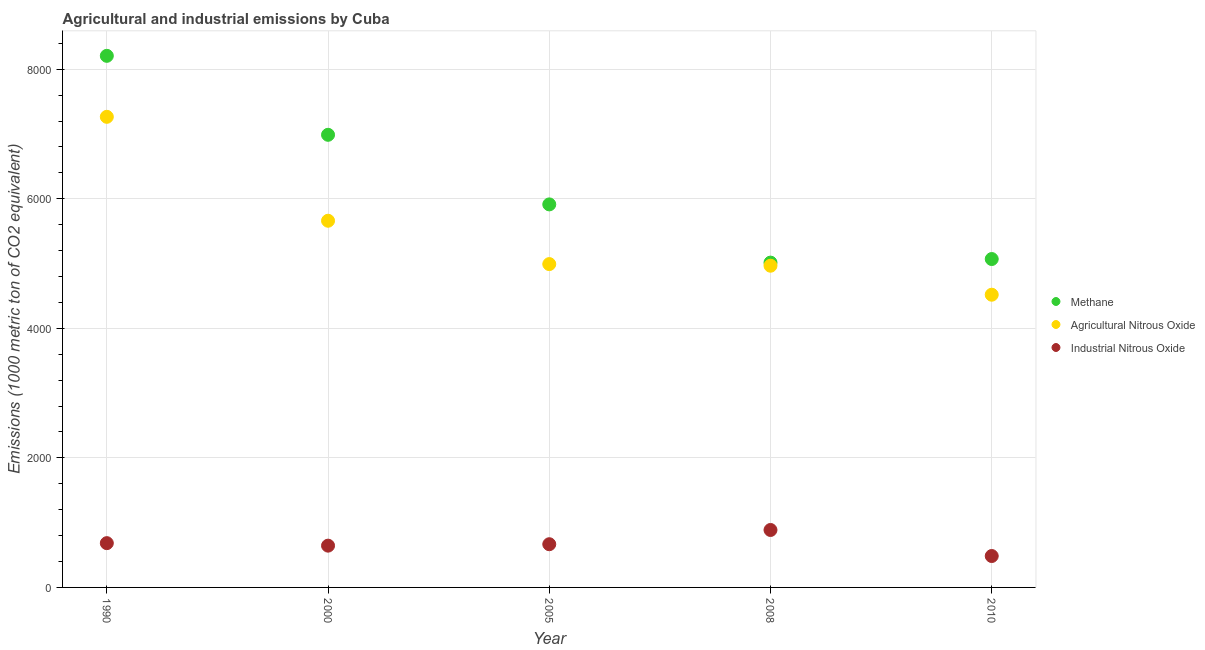Is the number of dotlines equal to the number of legend labels?
Provide a short and direct response. Yes. What is the amount of methane emissions in 1990?
Ensure brevity in your answer.  8207.5. Across all years, what is the maximum amount of methane emissions?
Keep it short and to the point. 8207.5. Across all years, what is the minimum amount of agricultural nitrous oxide emissions?
Provide a succinct answer. 4519.3. In which year was the amount of agricultural nitrous oxide emissions maximum?
Provide a short and direct response. 1990. In which year was the amount of industrial nitrous oxide emissions minimum?
Provide a succinct answer. 2010. What is the total amount of methane emissions in the graph?
Ensure brevity in your answer.  3.12e+04. What is the difference between the amount of agricultural nitrous oxide emissions in 2005 and that in 2008?
Keep it short and to the point. 25.1. What is the difference between the amount of agricultural nitrous oxide emissions in 2010 and the amount of industrial nitrous oxide emissions in 1990?
Keep it short and to the point. 3835.7. What is the average amount of methane emissions per year?
Offer a very short reply. 6238.96. In the year 2008, what is the difference between the amount of agricultural nitrous oxide emissions and amount of methane emissions?
Make the answer very short. -48. What is the ratio of the amount of methane emissions in 1990 to that in 2005?
Your response must be concise. 1.39. Is the amount of methane emissions in 2000 less than that in 2005?
Provide a succinct answer. No. What is the difference between the highest and the second highest amount of methane emissions?
Ensure brevity in your answer.  1219.2. What is the difference between the highest and the lowest amount of industrial nitrous oxide emissions?
Ensure brevity in your answer.  402. Is the sum of the amount of agricultural nitrous oxide emissions in 2000 and 2005 greater than the maximum amount of methane emissions across all years?
Provide a succinct answer. Yes. Is it the case that in every year, the sum of the amount of methane emissions and amount of agricultural nitrous oxide emissions is greater than the amount of industrial nitrous oxide emissions?
Make the answer very short. Yes. Does the amount of industrial nitrous oxide emissions monotonically increase over the years?
Ensure brevity in your answer.  No. Are the values on the major ticks of Y-axis written in scientific E-notation?
Ensure brevity in your answer.  No. Does the graph contain any zero values?
Offer a terse response. No. Does the graph contain grids?
Give a very brief answer. Yes. How are the legend labels stacked?
Make the answer very short. Vertical. What is the title of the graph?
Keep it short and to the point. Agricultural and industrial emissions by Cuba. What is the label or title of the X-axis?
Offer a very short reply. Year. What is the label or title of the Y-axis?
Provide a short and direct response. Emissions (1000 metric ton of CO2 equivalent). What is the Emissions (1000 metric ton of CO2 equivalent) of Methane in 1990?
Give a very brief answer. 8207.5. What is the Emissions (1000 metric ton of CO2 equivalent) in Agricultural Nitrous Oxide in 1990?
Your answer should be very brief. 7265.9. What is the Emissions (1000 metric ton of CO2 equivalent) in Industrial Nitrous Oxide in 1990?
Offer a terse response. 683.6. What is the Emissions (1000 metric ton of CO2 equivalent) in Methane in 2000?
Ensure brevity in your answer.  6988.3. What is the Emissions (1000 metric ton of CO2 equivalent) of Agricultural Nitrous Oxide in 2000?
Give a very brief answer. 5661.3. What is the Emissions (1000 metric ton of CO2 equivalent) in Industrial Nitrous Oxide in 2000?
Provide a short and direct response. 645. What is the Emissions (1000 metric ton of CO2 equivalent) in Methane in 2005?
Your answer should be compact. 5913.8. What is the Emissions (1000 metric ton of CO2 equivalent) in Agricultural Nitrous Oxide in 2005?
Offer a terse response. 4992.1. What is the Emissions (1000 metric ton of CO2 equivalent) in Industrial Nitrous Oxide in 2005?
Ensure brevity in your answer.  667.1. What is the Emissions (1000 metric ton of CO2 equivalent) in Methane in 2008?
Provide a short and direct response. 5015. What is the Emissions (1000 metric ton of CO2 equivalent) in Agricultural Nitrous Oxide in 2008?
Make the answer very short. 4967. What is the Emissions (1000 metric ton of CO2 equivalent) in Industrial Nitrous Oxide in 2008?
Give a very brief answer. 886.9. What is the Emissions (1000 metric ton of CO2 equivalent) in Methane in 2010?
Offer a terse response. 5070.2. What is the Emissions (1000 metric ton of CO2 equivalent) in Agricultural Nitrous Oxide in 2010?
Offer a very short reply. 4519.3. What is the Emissions (1000 metric ton of CO2 equivalent) of Industrial Nitrous Oxide in 2010?
Give a very brief answer. 484.9. Across all years, what is the maximum Emissions (1000 metric ton of CO2 equivalent) in Methane?
Provide a short and direct response. 8207.5. Across all years, what is the maximum Emissions (1000 metric ton of CO2 equivalent) of Agricultural Nitrous Oxide?
Make the answer very short. 7265.9. Across all years, what is the maximum Emissions (1000 metric ton of CO2 equivalent) of Industrial Nitrous Oxide?
Provide a short and direct response. 886.9. Across all years, what is the minimum Emissions (1000 metric ton of CO2 equivalent) in Methane?
Provide a short and direct response. 5015. Across all years, what is the minimum Emissions (1000 metric ton of CO2 equivalent) in Agricultural Nitrous Oxide?
Make the answer very short. 4519.3. Across all years, what is the minimum Emissions (1000 metric ton of CO2 equivalent) in Industrial Nitrous Oxide?
Your response must be concise. 484.9. What is the total Emissions (1000 metric ton of CO2 equivalent) in Methane in the graph?
Ensure brevity in your answer.  3.12e+04. What is the total Emissions (1000 metric ton of CO2 equivalent) in Agricultural Nitrous Oxide in the graph?
Ensure brevity in your answer.  2.74e+04. What is the total Emissions (1000 metric ton of CO2 equivalent) of Industrial Nitrous Oxide in the graph?
Ensure brevity in your answer.  3367.5. What is the difference between the Emissions (1000 metric ton of CO2 equivalent) in Methane in 1990 and that in 2000?
Your answer should be very brief. 1219.2. What is the difference between the Emissions (1000 metric ton of CO2 equivalent) in Agricultural Nitrous Oxide in 1990 and that in 2000?
Your answer should be compact. 1604.6. What is the difference between the Emissions (1000 metric ton of CO2 equivalent) in Industrial Nitrous Oxide in 1990 and that in 2000?
Offer a very short reply. 38.6. What is the difference between the Emissions (1000 metric ton of CO2 equivalent) of Methane in 1990 and that in 2005?
Your answer should be compact. 2293.7. What is the difference between the Emissions (1000 metric ton of CO2 equivalent) of Agricultural Nitrous Oxide in 1990 and that in 2005?
Provide a succinct answer. 2273.8. What is the difference between the Emissions (1000 metric ton of CO2 equivalent) in Industrial Nitrous Oxide in 1990 and that in 2005?
Offer a very short reply. 16.5. What is the difference between the Emissions (1000 metric ton of CO2 equivalent) of Methane in 1990 and that in 2008?
Provide a short and direct response. 3192.5. What is the difference between the Emissions (1000 metric ton of CO2 equivalent) of Agricultural Nitrous Oxide in 1990 and that in 2008?
Provide a short and direct response. 2298.9. What is the difference between the Emissions (1000 metric ton of CO2 equivalent) of Industrial Nitrous Oxide in 1990 and that in 2008?
Offer a terse response. -203.3. What is the difference between the Emissions (1000 metric ton of CO2 equivalent) in Methane in 1990 and that in 2010?
Your response must be concise. 3137.3. What is the difference between the Emissions (1000 metric ton of CO2 equivalent) in Agricultural Nitrous Oxide in 1990 and that in 2010?
Provide a succinct answer. 2746.6. What is the difference between the Emissions (1000 metric ton of CO2 equivalent) in Industrial Nitrous Oxide in 1990 and that in 2010?
Ensure brevity in your answer.  198.7. What is the difference between the Emissions (1000 metric ton of CO2 equivalent) of Methane in 2000 and that in 2005?
Provide a short and direct response. 1074.5. What is the difference between the Emissions (1000 metric ton of CO2 equivalent) of Agricultural Nitrous Oxide in 2000 and that in 2005?
Provide a short and direct response. 669.2. What is the difference between the Emissions (1000 metric ton of CO2 equivalent) of Industrial Nitrous Oxide in 2000 and that in 2005?
Provide a succinct answer. -22.1. What is the difference between the Emissions (1000 metric ton of CO2 equivalent) in Methane in 2000 and that in 2008?
Offer a terse response. 1973.3. What is the difference between the Emissions (1000 metric ton of CO2 equivalent) of Agricultural Nitrous Oxide in 2000 and that in 2008?
Offer a terse response. 694.3. What is the difference between the Emissions (1000 metric ton of CO2 equivalent) in Industrial Nitrous Oxide in 2000 and that in 2008?
Offer a terse response. -241.9. What is the difference between the Emissions (1000 metric ton of CO2 equivalent) of Methane in 2000 and that in 2010?
Give a very brief answer. 1918.1. What is the difference between the Emissions (1000 metric ton of CO2 equivalent) in Agricultural Nitrous Oxide in 2000 and that in 2010?
Offer a very short reply. 1142. What is the difference between the Emissions (1000 metric ton of CO2 equivalent) in Industrial Nitrous Oxide in 2000 and that in 2010?
Keep it short and to the point. 160.1. What is the difference between the Emissions (1000 metric ton of CO2 equivalent) in Methane in 2005 and that in 2008?
Offer a terse response. 898.8. What is the difference between the Emissions (1000 metric ton of CO2 equivalent) of Agricultural Nitrous Oxide in 2005 and that in 2008?
Provide a short and direct response. 25.1. What is the difference between the Emissions (1000 metric ton of CO2 equivalent) in Industrial Nitrous Oxide in 2005 and that in 2008?
Provide a succinct answer. -219.8. What is the difference between the Emissions (1000 metric ton of CO2 equivalent) in Methane in 2005 and that in 2010?
Give a very brief answer. 843.6. What is the difference between the Emissions (1000 metric ton of CO2 equivalent) in Agricultural Nitrous Oxide in 2005 and that in 2010?
Make the answer very short. 472.8. What is the difference between the Emissions (1000 metric ton of CO2 equivalent) of Industrial Nitrous Oxide in 2005 and that in 2010?
Provide a succinct answer. 182.2. What is the difference between the Emissions (1000 metric ton of CO2 equivalent) of Methane in 2008 and that in 2010?
Keep it short and to the point. -55.2. What is the difference between the Emissions (1000 metric ton of CO2 equivalent) in Agricultural Nitrous Oxide in 2008 and that in 2010?
Your answer should be compact. 447.7. What is the difference between the Emissions (1000 metric ton of CO2 equivalent) in Industrial Nitrous Oxide in 2008 and that in 2010?
Your response must be concise. 402. What is the difference between the Emissions (1000 metric ton of CO2 equivalent) of Methane in 1990 and the Emissions (1000 metric ton of CO2 equivalent) of Agricultural Nitrous Oxide in 2000?
Give a very brief answer. 2546.2. What is the difference between the Emissions (1000 metric ton of CO2 equivalent) in Methane in 1990 and the Emissions (1000 metric ton of CO2 equivalent) in Industrial Nitrous Oxide in 2000?
Offer a very short reply. 7562.5. What is the difference between the Emissions (1000 metric ton of CO2 equivalent) of Agricultural Nitrous Oxide in 1990 and the Emissions (1000 metric ton of CO2 equivalent) of Industrial Nitrous Oxide in 2000?
Keep it short and to the point. 6620.9. What is the difference between the Emissions (1000 metric ton of CO2 equivalent) of Methane in 1990 and the Emissions (1000 metric ton of CO2 equivalent) of Agricultural Nitrous Oxide in 2005?
Ensure brevity in your answer.  3215.4. What is the difference between the Emissions (1000 metric ton of CO2 equivalent) of Methane in 1990 and the Emissions (1000 metric ton of CO2 equivalent) of Industrial Nitrous Oxide in 2005?
Make the answer very short. 7540.4. What is the difference between the Emissions (1000 metric ton of CO2 equivalent) in Agricultural Nitrous Oxide in 1990 and the Emissions (1000 metric ton of CO2 equivalent) in Industrial Nitrous Oxide in 2005?
Offer a very short reply. 6598.8. What is the difference between the Emissions (1000 metric ton of CO2 equivalent) of Methane in 1990 and the Emissions (1000 metric ton of CO2 equivalent) of Agricultural Nitrous Oxide in 2008?
Your answer should be very brief. 3240.5. What is the difference between the Emissions (1000 metric ton of CO2 equivalent) in Methane in 1990 and the Emissions (1000 metric ton of CO2 equivalent) in Industrial Nitrous Oxide in 2008?
Offer a very short reply. 7320.6. What is the difference between the Emissions (1000 metric ton of CO2 equivalent) in Agricultural Nitrous Oxide in 1990 and the Emissions (1000 metric ton of CO2 equivalent) in Industrial Nitrous Oxide in 2008?
Provide a short and direct response. 6379. What is the difference between the Emissions (1000 metric ton of CO2 equivalent) of Methane in 1990 and the Emissions (1000 metric ton of CO2 equivalent) of Agricultural Nitrous Oxide in 2010?
Offer a terse response. 3688.2. What is the difference between the Emissions (1000 metric ton of CO2 equivalent) of Methane in 1990 and the Emissions (1000 metric ton of CO2 equivalent) of Industrial Nitrous Oxide in 2010?
Your answer should be very brief. 7722.6. What is the difference between the Emissions (1000 metric ton of CO2 equivalent) in Agricultural Nitrous Oxide in 1990 and the Emissions (1000 metric ton of CO2 equivalent) in Industrial Nitrous Oxide in 2010?
Your response must be concise. 6781. What is the difference between the Emissions (1000 metric ton of CO2 equivalent) in Methane in 2000 and the Emissions (1000 metric ton of CO2 equivalent) in Agricultural Nitrous Oxide in 2005?
Ensure brevity in your answer.  1996.2. What is the difference between the Emissions (1000 metric ton of CO2 equivalent) in Methane in 2000 and the Emissions (1000 metric ton of CO2 equivalent) in Industrial Nitrous Oxide in 2005?
Your answer should be very brief. 6321.2. What is the difference between the Emissions (1000 metric ton of CO2 equivalent) of Agricultural Nitrous Oxide in 2000 and the Emissions (1000 metric ton of CO2 equivalent) of Industrial Nitrous Oxide in 2005?
Offer a very short reply. 4994.2. What is the difference between the Emissions (1000 metric ton of CO2 equivalent) of Methane in 2000 and the Emissions (1000 metric ton of CO2 equivalent) of Agricultural Nitrous Oxide in 2008?
Keep it short and to the point. 2021.3. What is the difference between the Emissions (1000 metric ton of CO2 equivalent) in Methane in 2000 and the Emissions (1000 metric ton of CO2 equivalent) in Industrial Nitrous Oxide in 2008?
Offer a very short reply. 6101.4. What is the difference between the Emissions (1000 metric ton of CO2 equivalent) in Agricultural Nitrous Oxide in 2000 and the Emissions (1000 metric ton of CO2 equivalent) in Industrial Nitrous Oxide in 2008?
Offer a very short reply. 4774.4. What is the difference between the Emissions (1000 metric ton of CO2 equivalent) in Methane in 2000 and the Emissions (1000 metric ton of CO2 equivalent) in Agricultural Nitrous Oxide in 2010?
Offer a very short reply. 2469. What is the difference between the Emissions (1000 metric ton of CO2 equivalent) of Methane in 2000 and the Emissions (1000 metric ton of CO2 equivalent) of Industrial Nitrous Oxide in 2010?
Give a very brief answer. 6503.4. What is the difference between the Emissions (1000 metric ton of CO2 equivalent) of Agricultural Nitrous Oxide in 2000 and the Emissions (1000 metric ton of CO2 equivalent) of Industrial Nitrous Oxide in 2010?
Your answer should be compact. 5176.4. What is the difference between the Emissions (1000 metric ton of CO2 equivalent) of Methane in 2005 and the Emissions (1000 metric ton of CO2 equivalent) of Agricultural Nitrous Oxide in 2008?
Give a very brief answer. 946.8. What is the difference between the Emissions (1000 metric ton of CO2 equivalent) in Methane in 2005 and the Emissions (1000 metric ton of CO2 equivalent) in Industrial Nitrous Oxide in 2008?
Your answer should be compact. 5026.9. What is the difference between the Emissions (1000 metric ton of CO2 equivalent) of Agricultural Nitrous Oxide in 2005 and the Emissions (1000 metric ton of CO2 equivalent) of Industrial Nitrous Oxide in 2008?
Your answer should be very brief. 4105.2. What is the difference between the Emissions (1000 metric ton of CO2 equivalent) of Methane in 2005 and the Emissions (1000 metric ton of CO2 equivalent) of Agricultural Nitrous Oxide in 2010?
Provide a short and direct response. 1394.5. What is the difference between the Emissions (1000 metric ton of CO2 equivalent) in Methane in 2005 and the Emissions (1000 metric ton of CO2 equivalent) in Industrial Nitrous Oxide in 2010?
Offer a very short reply. 5428.9. What is the difference between the Emissions (1000 metric ton of CO2 equivalent) in Agricultural Nitrous Oxide in 2005 and the Emissions (1000 metric ton of CO2 equivalent) in Industrial Nitrous Oxide in 2010?
Your response must be concise. 4507.2. What is the difference between the Emissions (1000 metric ton of CO2 equivalent) of Methane in 2008 and the Emissions (1000 metric ton of CO2 equivalent) of Agricultural Nitrous Oxide in 2010?
Offer a very short reply. 495.7. What is the difference between the Emissions (1000 metric ton of CO2 equivalent) of Methane in 2008 and the Emissions (1000 metric ton of CO2 equivalent) of Industrial Nitrous Oxide in 2010?
Ensure brevity in your answer.  4530.1. What is the difference between the Emissions (1000 metric ton of CO2 equivalent) of Agricultural Nitrous Oxide in 2008 and the Emissions (1000 metric ton of CO2 equivalent) of Industrial Nitrous Oxide in 2010?
Ensure brevity in your answer.  4482.1. What is the average Emissions (1000 metric ton of CO2 equivalent) of Methane per year?
Give a very brief answer. 6238.96. What is the average Emissions (1000 metric ton of CO2 equivalent) of Agricultural Nitrous Oxide per year?
Provide a succinct answer. 5481.12. What is the average Emissions (1000 metric ton of CO2 equivalent) in Industrial Nitrous Oxide per year?
Provide a succinct answer. 673.5. In the year 1990, what is the difference between the Emissions (1000 metric ton of CO2 equivalent) of Methane and Emissions (1000 metric ton of CO2 equivalent) of Agricultural Nitrous Oxide?
Keep it short and to the point. 941.6. In the year 1990, what is the difference between the Emissions (1000 metric ton of CO2 equivalent) of Methane and Emissions (1000 metric ton of CO2 equivalent) of Industrial Nitrous Oxide?
Provide a short and direct response. 7523.9. In the year 1990, what is the difference between the Emissions (1000 metric ton of CO2 equivalent) of Agricultural Nitrous Oxide and Emissions (1000 metric ton of CO2 equivalent) of Industrial Nitrous Oxide?
Offer a very short reply. 6582.3. In the year 2000, what is the difference between the Emissions (1000 metric ton of CO2 equivalent) in Methane and Emissions (1000 metric ton of CO2 equivalent) in Agricultural Nitrous Oxide?
Keep it short and to the point. 1327. In the year 2000, what is the difference between the Emissions (1000 metric ton of CO2 equivalent) of Methane and Emissions (1000 metric ton of CO2 equivalent) of Industrial Nitrous Oxide?
Give a very brief answer. 6343.3. In the year 2000, what is the difference between the Emissions (1000 metric ton of CO2 equivalent) in Agricultural Nitrous Oxide and Emissions (1000 metric ton of CO2 equivalent) in Industrial Nitrous Oxide?
Your response must be concise. 5016.3. In the year 2005, what is the difference between the Emissions (1000 metric ton of CO2 equivalent) in Methane and Emissions (1000 metric ton of CO2 equivalent) in Agricultural Nitrous Oxide?
Your response must be concise. 921.7. In the year 2005, what is the difference between the Emissions (1000 metric ton of CO2 equivalent) in Methane and Emissions (1000 metric ton of CO2 equivalent) in Industrial Nitrous Oxide?
Provide a succinct answer. 5246.7. In the year 2005, what is the difference between the Emissions (1000 metric ton of CO2 equivalent) of Agricultural Nitrous Oxide and Emissions (1000 metric ton of CO2 equivalent) of Industrial Nitrous Oxide?
Offer a terse response. 4325. In the year 2008, what is the difference between the Emissions (1000 metric ton of CO2 equivalent) in Methane and Emissions (1000 metric ton of CO2 equivalent) in Agricultural Nitrous Oxide?
Provide a succinct answer. 48. In the year 2008, what is the difference between the Emissions (1000 metric ton of CO2 equivalent) in Methane and Emissions (1000 metric ton of CO2 equivalent) in Industrial Nitrous Oxide?
Offer a terse response. 4128.1. In the year 2008, what is the difference between the Emissions (1000 metric ton of CO2 equivalent) in Agricultural Nitrous Oxide and Emissions (1000 metric ton of CO2 equivalent) in Industrial Nitrous Oxide?
Keep it short and to the point. 4080.1. In the year 2010, what is the difference between the Emissions (1000 metric ton of CO2 equivalent) of Methane and Emissions (1000 metric ton of CO2 equivalent) of Agricultural Nitrous Oxide?
Provide a short and direct response. 550.9. In the year 2010, what is the difference between the Emissions (1000 metric ton of CO2 equivalent) in Methane and Emissions (1000 metric ton of CO2 equivalent) in Industrial Nitrous Oxide?
Keep it short and to the point. 4585.3. In the year 2010, what is the difference between the Emissions (1000 metric ton of CO2 equivalent) in Agricultural Nitrous Oxide and Emissions (1000 metric ton of CO2 equivalent) in Industrial Nitrous Oxide?
Make the answer very short. 4034.4. What is the ratio of the Emissions (1000 metric ton of CO2 equivalent) in Methane in 1990 to that in 2000?
Your answer should be compact. 1.17. What is the ratio of the Emissions (1000 metric ton of CO2 equivalent) in Agricultural Nitrous Oxide in 1990 to that in 2000?
Provide a succinct answer. 1.28. What is the ratio of the Emissions (1000 metric ton of CO2 equivalent) in Industrial Nitrous Oxide in 1990 to that in 2000?
Your answer should be compact. 1.06. What is the ratio of the Emissions (1000 metric ton of CO2 equivalent) in Methane in 1990 to that in 2005?
Give a very brief answer. 1.39. What is the ratio of the Emissions (1000 metric ton of CO2 equivalent) of Agricultural Nitrous Oxide in 1990 to that in 2005?
Keep it short and to the point. 1.46. What is the ratio of the Emissions (1000 metric ton of CO2 equivalent) in Industrial Nitrous Oxide in 1990 to that in 2005?
Your answer should be very brief. 1.02. What is the ratio of the Emissions (1000 metric ton of CO2 equivalent) in Methane in 1990 to that in 2008?
Ensure brevity in your answer.  1.64. What is the ratio of the Emissions (1000 metric ton of CO2 equivalent) in Agricultural Nitrous Oxide in 1990 to that in 2008?
Give a very brief answer. 1.46. What is the ratio of the Emissions (1000 metric ton of CO2 equivalent) in Industrial Nitrous Oxide in 1990 to that in 2008?
Give a very brief answer. 0.77. What is the ratio of the Emissions (1000 metric ton of CO2 equivalent) in Methane in 1990 to that in 2010?
Provide a short and direct response. 1.62. What is the ratio of the Emissions (1000 metric ton of CO2 equivalent) of Agricultural Nitrous Oxide in 1990 to that in 2010?
Offer a terse response. 1.61. What is the ratio of the Emissions (1000 metric ton of CO2 equivalent) in Industrial Nitrous Oxide in 1990 to that in 2010?
Provide a short and direct response. 1.41. What is the ratio of the Emissions (1000 metric ton of CO2 equivalent) in Methane in 2000 to that in 2005?
Your answer should be very brief. 1.18. What is the ratio of the Emissions (1000 metric ton of CO2 equivalent) of Agricultural Nitrous Oxide in 2000 to that in 2005?
Keep it short and to the point. 1.13. What is the ratio of the Emissions (1000 metric ton of CO2 equivalent) in Industrial Nitrous Oxide in 2000 to that in 2005?
Offer a terse response. 0.97. What is the ratio of the Emissions (1000 metric ton of CO2 equivalent) of Methane in 2000 to that in 2008?
Provide a short and direct response. 1.39. What is the ratio of the Emissions (1000 metric ton of CO2 equivalent) of Agricultural Nitrous Oxide in 2000 to that in 2008?
Make the answer very short. 1.14. What is the ratio of the Emissions (1000 metric ton of CO2 equivalent) in Industrial Nitrous Oxide in 2000 to that in 2008?
Make the answer very short. 0.73. What is the ratio of the Emissions (1000 metric ton of CO2 equivalent) of Methane in 2000 to that in 2010?
Offer a very short reply. 1.38. What is the ratio of the Emissions (1000 metric ton of CO2 equivalent) in Agricultural Nitrous Oxide in 2000 to that in 2010?
Offer a terse response. 1.25. What is the ratio of the Emissions (1000 metric ton of CO2 equivalent) of Industrial Nitrous Oxide in 2000 to that in 2010?
Provide a succinct answer. 1.33. What is the ratio of the Emissions (1000 metric ton of CO2 equivalent) in Methane in 2005 to that in 2008?
Make the answer very short. 1.18. What is the ratio of the Emissions (1000 metric ton of CO2 equivalent) in Industrial Nitrous Oxide in 2005 to that in 2008?
Provide a short and direct response. 0.75. What is the ratio of the Emissions (1000 metric ton of CO2 equivalent) of Methane in 2005 to that in 2010?
Your answer should be very brief. 1.17. What is the ratio of the Emissions (1000 metric ton of CO2 equivalent) of Agricultural Nitrous Oxide in 2005 to that in 2010?
Give a very brief answer. 1.1. What is the ratio of the Emissions (1000 metric ton of CO2 equivalent) of Industrial Nitrous Oxide in 2005 to that in 2010?
Offer a terse response. 1.38. What is the ratio of the Emissions (1000 metric ton of CO2 equivalent) in Agricultural Nitrous Oxide in 2008 to that in 2010?
Offer a terse response. 1.1. What is the ratio of the Emissions (1000 metric ton of CO2 equivalent) in Industrial Nitrous Oxide in 2008 to that in 2010?
Offer a terse response. 1.83. What is the difference between the highest and the second highest Emissions (1000 metric ton of CO2 equivalent) of Methane?
Give a very brief answer. 1219.2. What is the difference between the highest and the second highest Emissions (1000 metric ton of CO2 equivalent) in Agricultural Nitrous Oxide?
Provide a short and direct response. 1604.6. What is the difference between the highest and the second highest Emissions (1000 metric ton of CO2 equivalent) of Industrial Nitrous Oxide?
Keep it short and to the point. 203.3. What is the difference between the highest and the lowest Emissions (1000 metric ton of CO2 equivalent) in Methane?
Keep it short and to the point. 3192.5. What is the difference between the highest and the lowest Emissions (1000 metric ton of CO2 equivalent) of Agricultural Nitrous Oxide?
Give a very brief answer. 2746.6. What is the difference between the highest and the lowest Emissions (1000 metric ton of CO2 equivalent) of Industrial Nitrous Oxide?
Keep it short and to the point. 402. 